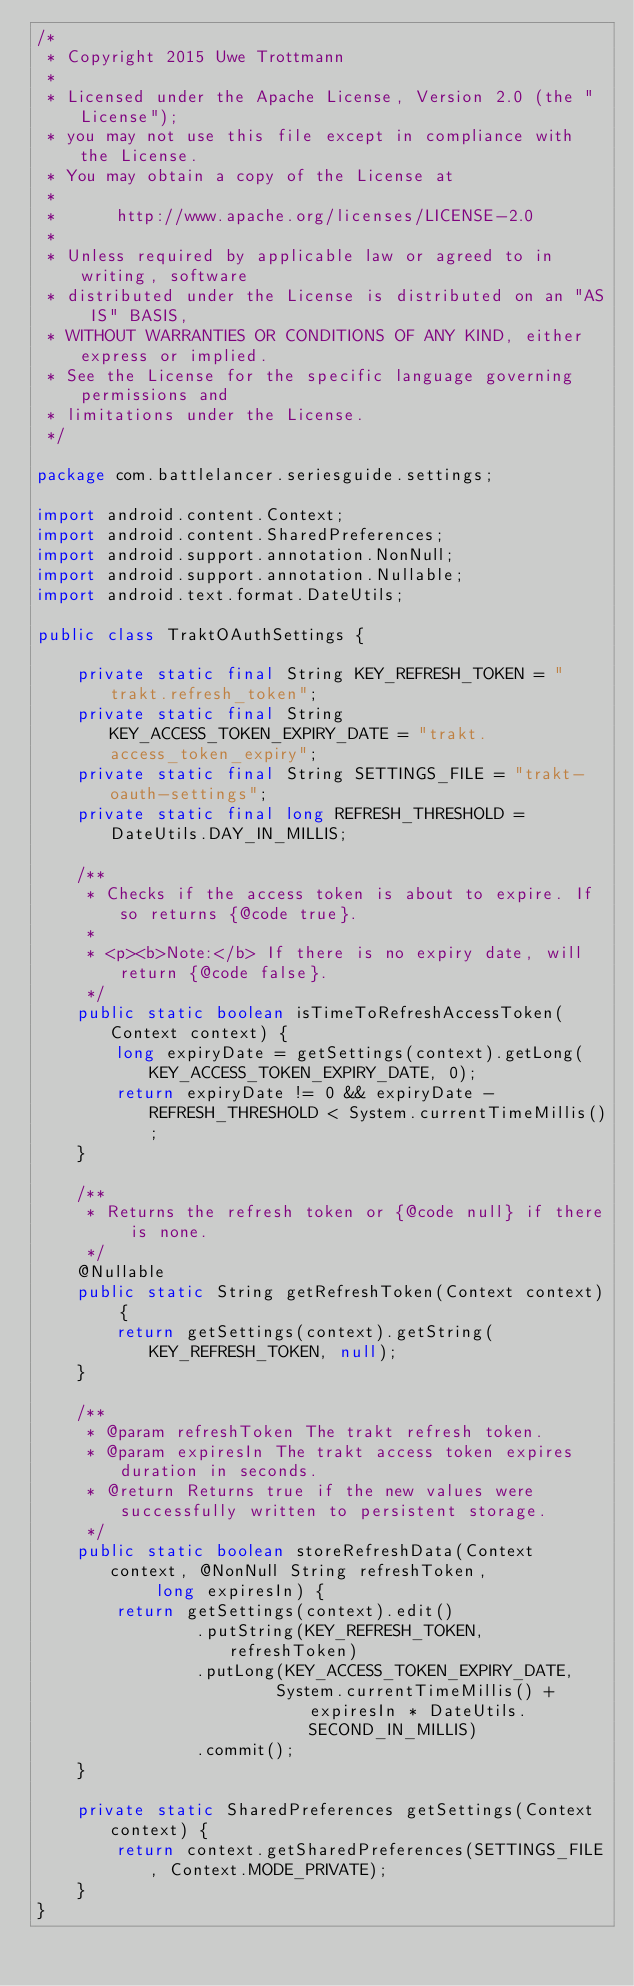<code> <loc_0><loc_0><loc_500><loc_500><_Java_>/*
 * Copyright 2015 Uwe Trottmann
 *
 * Licensed under the Apache License, Version 2.0 (the "License");
 * you may not use this file except in compliance with the License.
 * You may obtain a copy of the License at
 *
 *      http://www.apache.org/licenses/LICENSE-2.0
 *
 * Unless required by applicable law or agreed to in writing, software
 * distributed under the License is distributed on an "AS IS" BASIS,
 * WITHOUT WARRANTIES OR CONDITIONS OF ANY KIND, either express or implied.
 * See the License for the specific language governing permissions and
 * limitations under the License.
 */

package com.battlelancer.seriesguide.settings;

import android.content.Context;
import android.content.SharedPreferences;
import android.support.annotation.NonNull;
import android.support.annotation.Nullable;
import android.text.format.DateUtils;

public class TraktOAuthSettings {

    private static final String KEY_REFRESH_TOKEN = "trakt.refresh_token";
    private static final String KEY_ACCESS_TOKEN_EXPIRY_DATE = "trakt.access_token_expiry";
    private static final String SETTINGS_FILE = "trakt-oauth-settings";
    private static final long REFRESH_THRESHOLD = DateUtils.DAY_IN_MILLIS;

    /**
     * Checks if the access token is about to expire. If so returns {@code true}.
     *
     * <p><b>Note:</b> If there is no expiry date, will return {@code false}.
     */
    public static boolean isTimeToRefreshAccessToken(Context context) {
        long expiryDate = getSettings(context).getLong(KEY_ACCESS_TOKEN_EXPIRY_DATE, 0);
        return expiryDate != 0 && expiryDate - REFRESH_THRESHOLD < System.currentTimeMillis();
    }

    /**
     * Returns the refresh token or {@code null} if there is none.
     */
    @Nullable
    public static String getRefreshToken(Context context) {
        return getSettings(context).getString(KEY_REFRESH_TOKEN, null);
    }

    /**
     * @param refreshToken The trakt refresh token.
     * @param expiresIn The trakt access token expires duration in seconds.
     * @return Returns true if the new values were successfully written to persistent storage.
     */
    public static boolean storeRefreshData(Context context, @NonNull String refreshToken,
            long expiresIn) {
        return getSettings(context).edit()
                .putString(KEY_REFRESH_TOKEN, refreshToken)
                .putLong(KEY_ACCESS_TOKEN_EXPIRY_DATE,
                        System.currentTimeMillis() + expiresIn * DateUtils.SECOND_IN_MILLIS)
                .commit();
    }

    private static SharedPreferences getSettings(Context context) {
        return context.getSharedPreferences(SETTINGS_FILE, Context.MODE_PRIVATE);
    }
}
</code> 